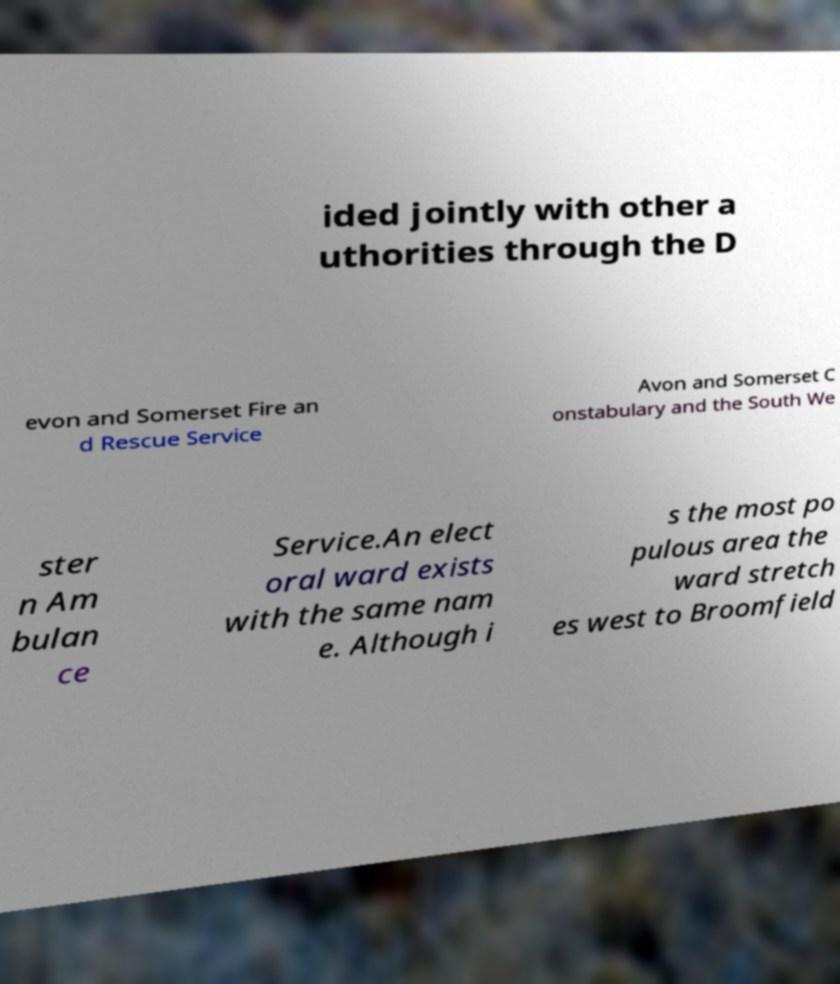Please read and relay the text visible in this image. What does it say? ided jointly with other a uthorities through the D evon and Somerset Fire an d Rescue Service Avon and Somerset C onstabulary and the South We ster n Am bulan ce Service.An elect oral ward exists with the same nam e. Although i s the most po pulous area the ward stretch es west to Broomfield 